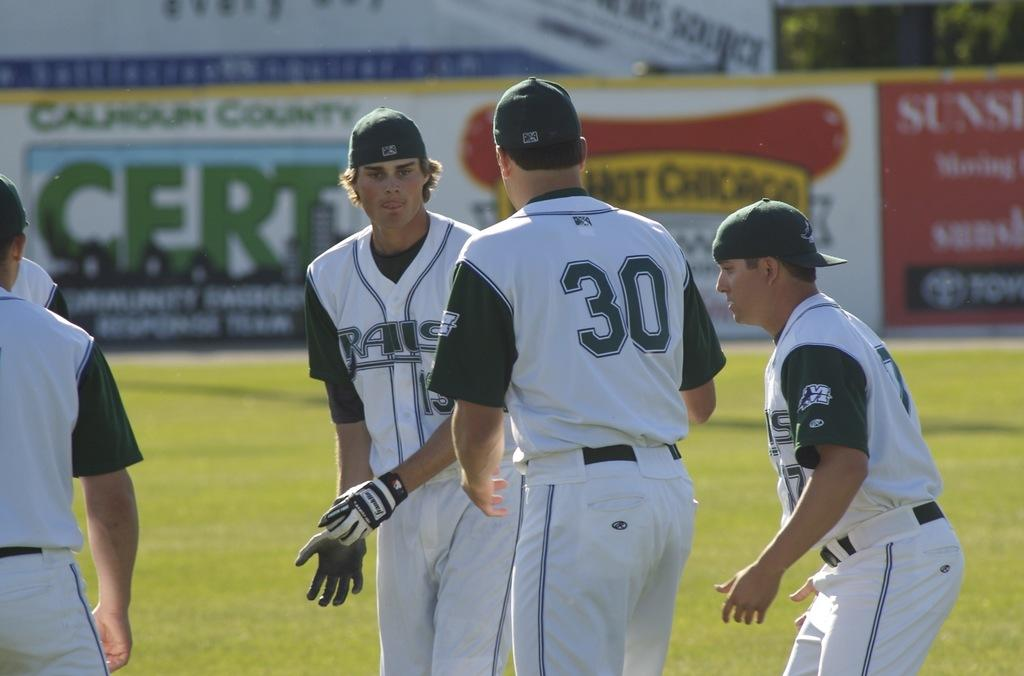<image>
Render a clear and concise summary of the photo. Baseball players #30 talks to his teammates on the Rails team. 